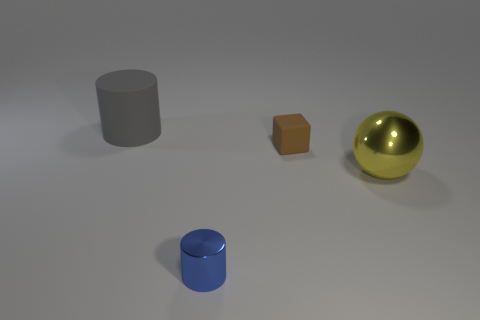What number of gray cylinders are made of the same material as the small brown block?
Offer a very short reply. 1. Do the matte thing in front of the rubber cylinder and the yellow sphere have the same size?
Offer a terse response. No. What is the color of the block that is the same size as the blue metal thing?
Offer a very short reply. Brown. What number of blue metallic cylinders are left of the large gray rubber cylinder?
Provide a short and direct response. 0. Are any tiny gray metallic balls visible?
Provide a succinct answer. No. How big is the cylinder in front of the big thing right of the big thing on the left side of the large sphere?
Give a very brief answer. Small. What number of other things are the same size as the blue cylinder?
Your response must be concise. 1. There is a rubber object in front of the big rubber thing; what size is it?
Offer a very short reply. Small. Are there any other things that have the same color as the cube?
Offer a terse response. No. Is the tiny thing right of the metallic cylinder made of the same material as the big gray thing?
Provide a succinct answer. Yes. 